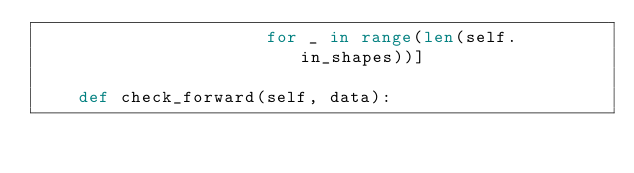<code> <loc_0><loc_0><loc_500><loc_500><_Python_>                      for _ in range(len(self.in_shapes))]

    def check_forward(self, data):</code> 